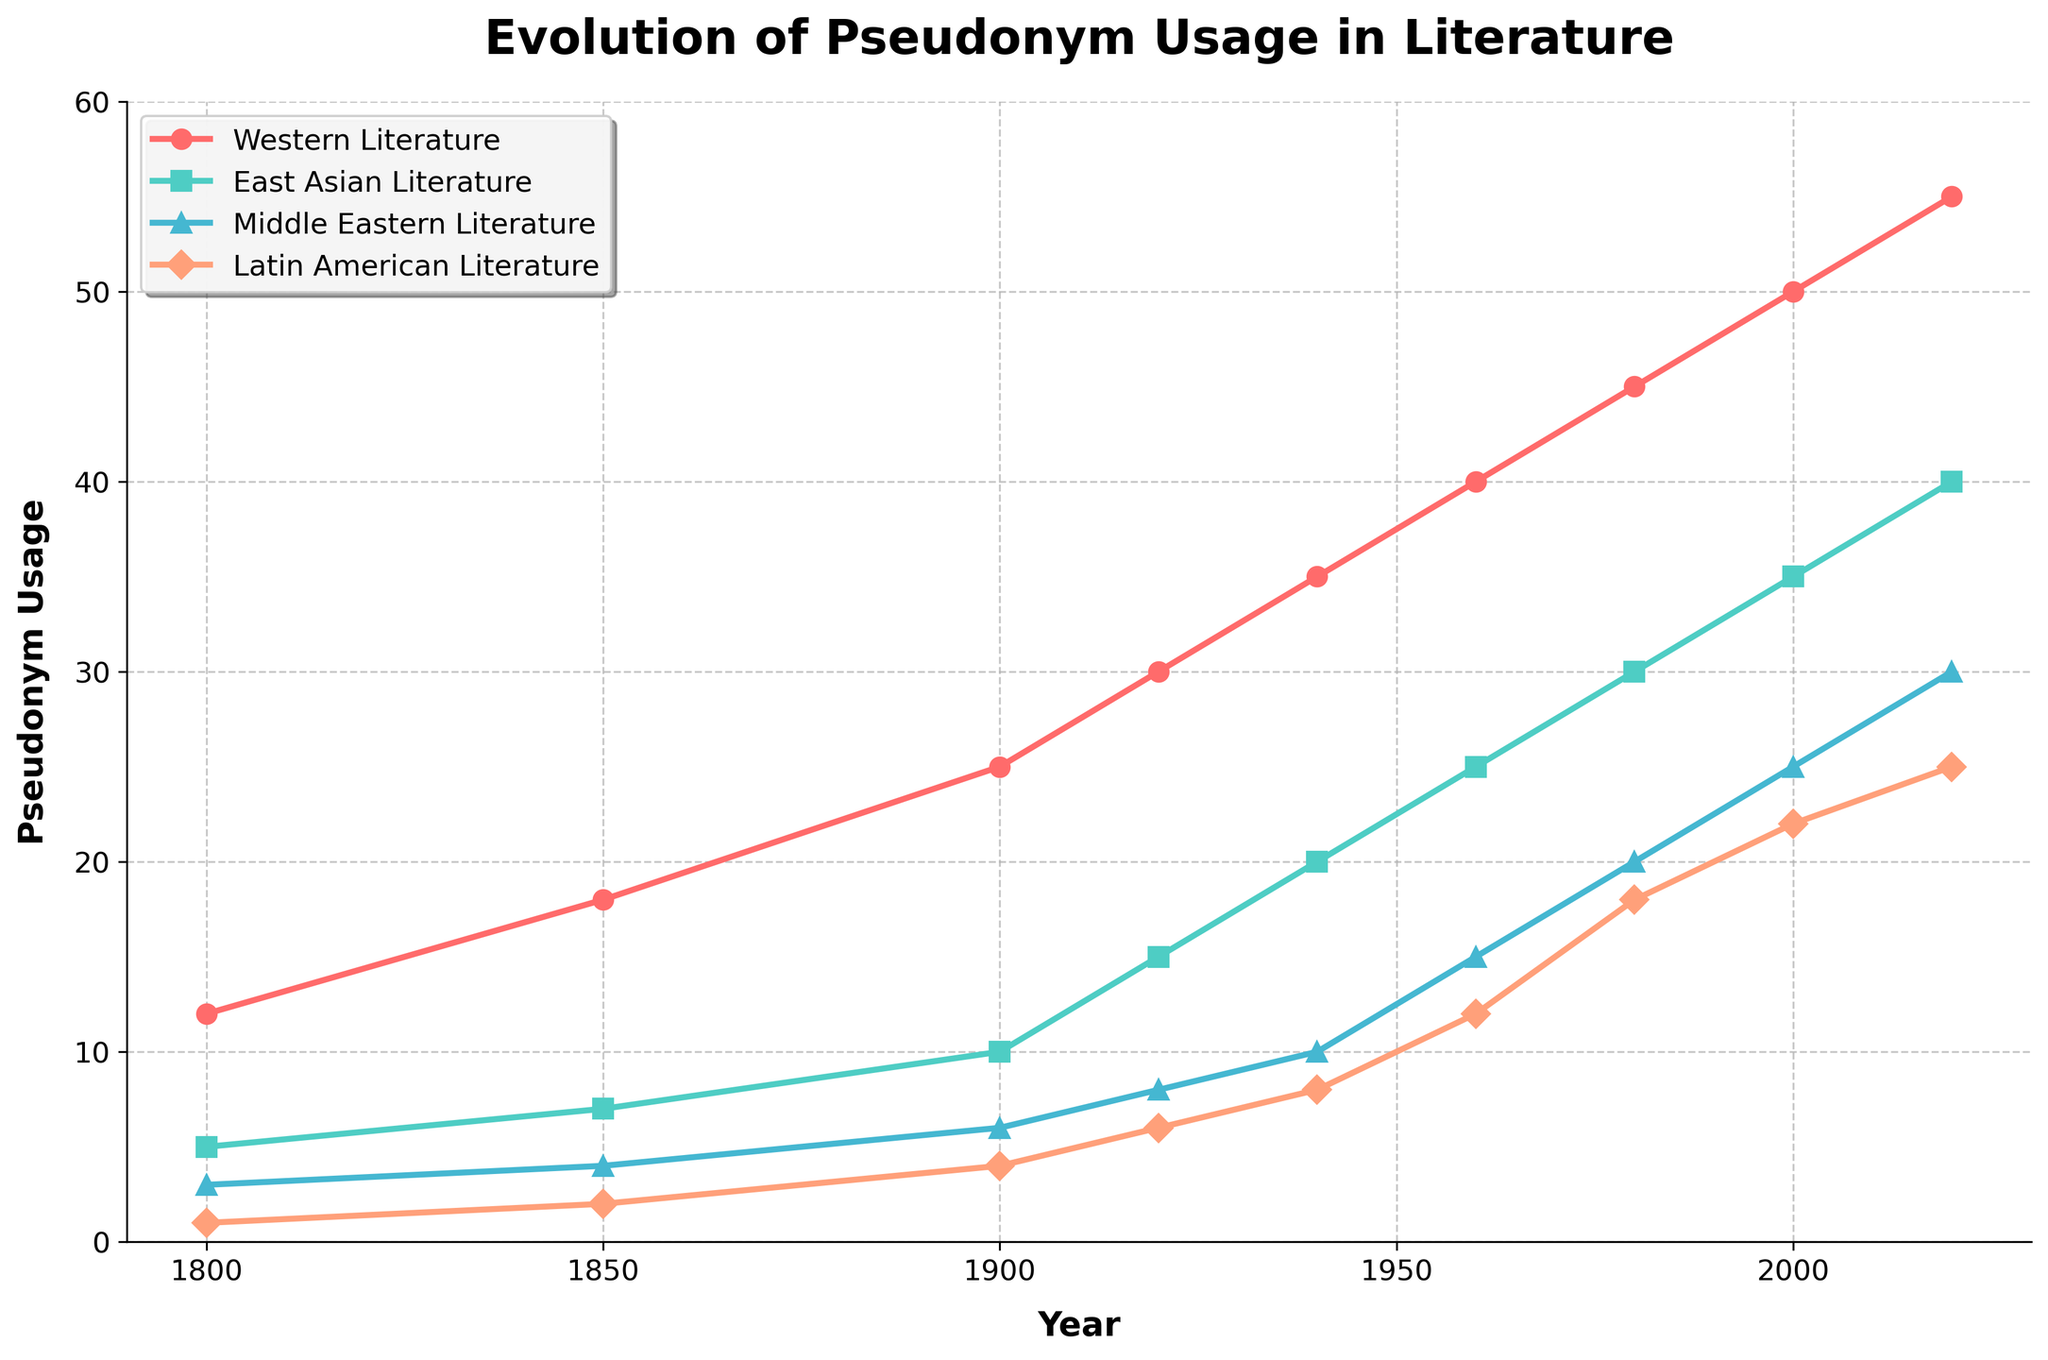What trend do you observe in Western Literature from 1800 to 2020? The plot shows a steady increase in pseudonym usage in Western Literature from 12 in 1800 to 55 in 2020, indicating a consistent rise over time without any decline
Answer: Steady increase Which culture had the most pseudonym usage in 1980? By visual inspection, Western Literature had the highest pseudonym usage with a value of 45, which is the tallest point in the year 1980 compared to the other cultures
Answer: Western Literature What is the sum of pseudonym usage in Western Literature and East Asian Literature in 2020? Western Literature had a usage of 55 and East Asian Literature had 40 in 2020. Summing these values: 55 + 40 = 95
Answer: 95 Between which two consecutive periods did Latin American Literature see the largest increase? The largest increase for Latin American Literature occurred from 1960 to 1980, where we see a rise from 12 to 18, an increase of 6
Answer: 1960-1980 Which culture exhibited the fastest growth between 1920 and 1940? The growth rates between 1920 and 1940 are: Western Literature (35-30=5), East Asian Literature (20-15=5), Middle Eastern Literature (10-8=2), and Latin American Literature (8-6=2). Both Western and East Asian Literature displayed the highest growth of 5, but not the fastest.
Answer: Western & East Asian Which culture had the least pseudonym usage in 2000? The least pseudonym usage in 2000 was observed in Middle Eastern Literature with a value of 25, which is the lowest point among the cultures displayed in this year
Answer: Middle Eastern Literature How does the growth rate in Middle Eastern Literature between 1900 and 1960 compare to that in Western Literature for the same period? Middle Eastern Literature grew from 6 to 15 (an increase of 9), while Western Literature grew from 25 to 40 (an increase of 15). Comparing these, Western Literature had a greater growth rate
Answer: Western Literature had greater growth What are the values used to compute the growth rate of pseudonym usage in East Asian Literature from 1980 to 2020? From 1980 (30) to 2020 (40): Growth Rate = (40-30)/30 * 100% = 10/30 * 100% = 33.33%
Answer: 33.33% Which cultures had equal pseudonym usage in any given year, if any? Both Middle Eastern and Latin American Literature had equal pseudonym usage of 8 in 1940
Answer: Middle Eastern & Latin American in 1940 Find the average pseudonym usage in Western Literature from 1800 to 2020. Summing up values: 12 + 18 + 25 + 30 + 35 + 40 + 45 + 50 + 55 = 310. Counting them gives 9 periods. So the average is 310/9 ≈ 34.44
Answer: 34.44 